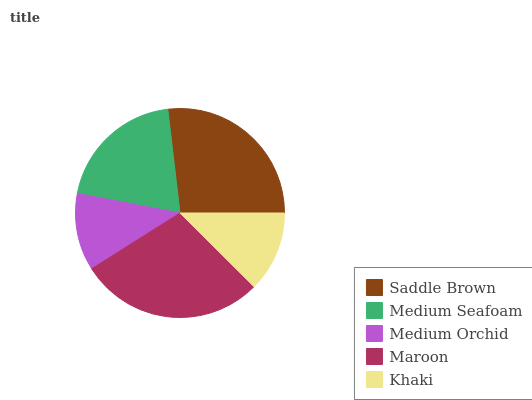Is Medium Orchid the minimum?
Answer yes or no. Yes. Is Maroon the maximum?
Answer yes or no. Yes. Is Medium Seafoam the minimum?
Answer yes or no. No. Is Medium Seafoam the maximum?
Answer yes or no. No. Is Saddle Brown greater than Medium Seafoam?
Answer yes or no. Yes. Is Medium Seafoam less than Saddle Brown?
Answer yes or no. Yes. Is Medium Seafoam greater than Saddle Brown?
Answer yes or no. No. Is Saddle Brown less than Medium Seafoam?
Answer yes or no. No. Is Medium Seafoam the high median?
Answer yes or no. Yes. Is Medium Seafoam the low median?
Answer yes or no. Yes. Is Maroon the high median?
Answer yes or no. No. Is Medium Orchid the low median?
Answer yes or no. No. 